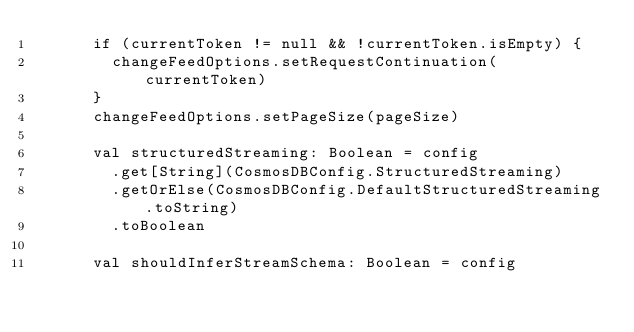<code> <loc_0><loc_0><loc_500><loc_500><_Scala_>      if (currentToken != null && !currentToken.isEmpty) {
        changeFeedOptions.setRequestContinuation(currentToken)
      }
      changeFeedOptions.setPageSize(pageSize)

      val structuredStreaming: Boolean = config
        .get[String](CosmosDBConfig.StructuredStreaming)
        .getOrElse(CosmosDBConfig.DefaultStructuredStreaming.toString)
        .toBoolean

      val shouldInferStreamSchema: Boolean = config</code> 